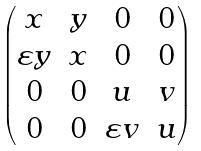<formula> <loc_0><loc_0><loc_500><loc_500>\begin{pmatrix} x & y & 0 & 0 \\ \varepsilon y & x & 0 & 0 \\ 0 & 0 & u & v \\ 0 & 0 & \varepsilon v & u \end{pmatrix}</formula> 